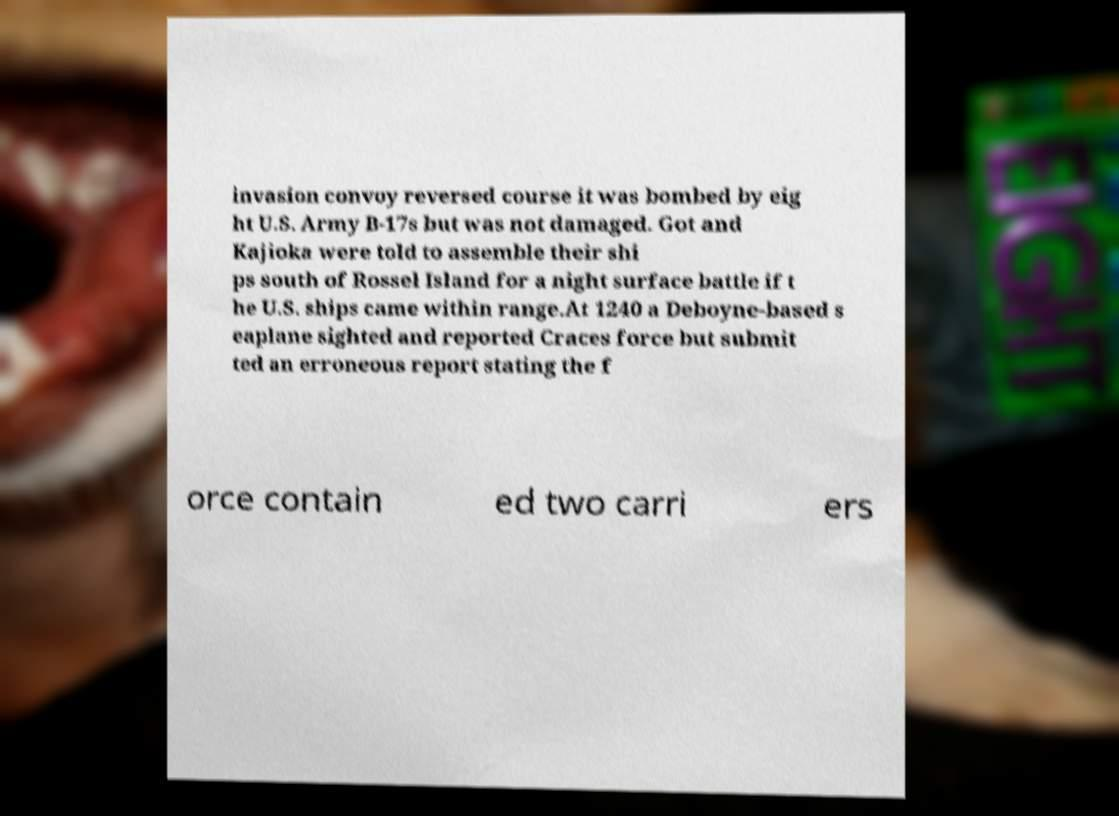Please identify and transcribe the text found in this image. invasion convoy reversed course it was bombed by eig ht U.S. Army B-17s but was not damaged. Got and Kajioka were told to assemble their shi ps south of Rossel Island for a night surface battle if t he U.S. ships came within range.At 1240 a Deboyne-based s eaplane sighted and reported Craces force but submit ted an erroneous report stating the f orce contain ed two carri ers 